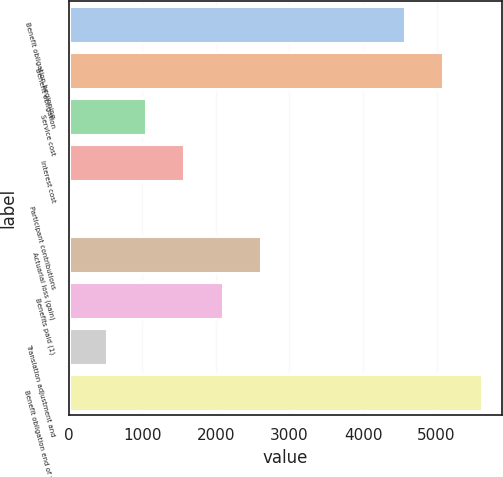Convert chart. <chart><loc_0><loc_0><loc_500><loc_500><bar_chart><fcel>Benefit obligation beginning<fcel>Benefit obligation<fcel>Service cost<fcel>Interest cost<fcel>Participant contributions<fcel>Actuarial loss (gain)<fcel>Benefits paid (1)<fcel>Translation adjustment and<fcel>Benefit obligation end of year<nl><fcel>4566<fcel>5089.2<fcel>1047.4<fcel>1570.6<fcel>1<fcel>2617<fcel>2093.8<fcel>524.2<fcel>5612.4<nl></chart> 